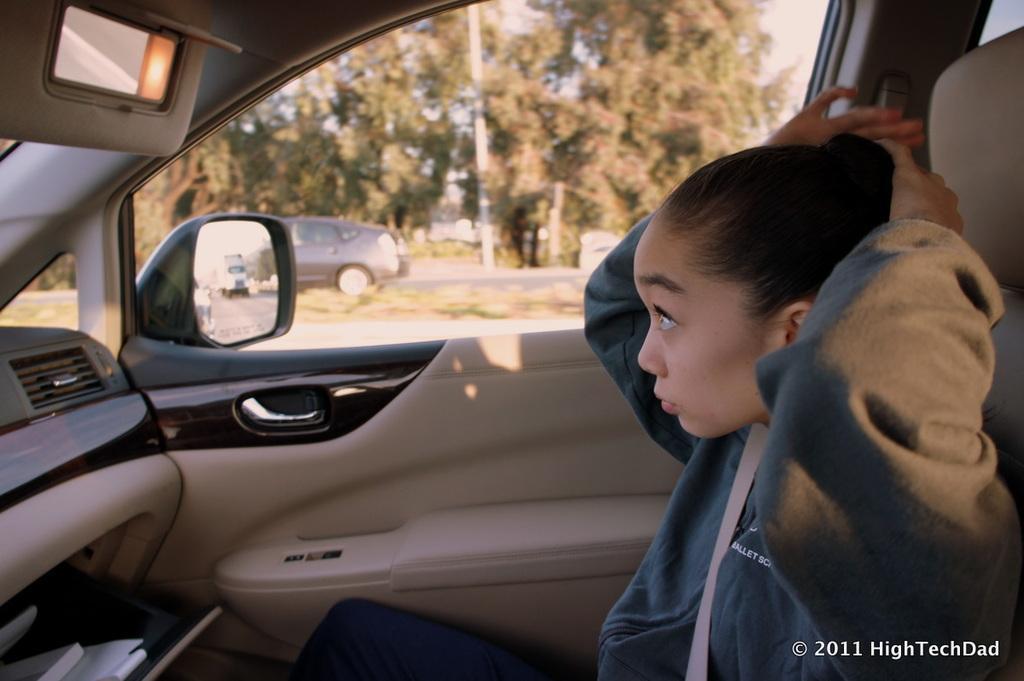Describe this image in one or two sentences. In this image i can see a woman sitting on the car, And on the back ground ground i can see trees and there is a another vehicle on the right side 